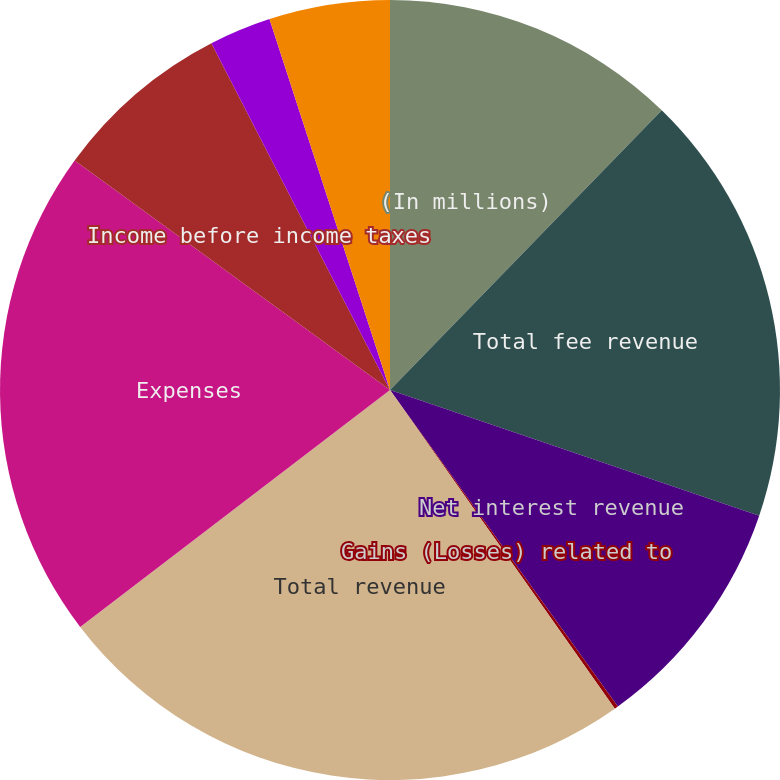<chart> <loc_0><loc_0><loc_500><loc_500><pie_chart><fcel>(In millions)<fcel>Total fee revenue<fcel>Net interest revenue<fcel>Gains (Losses) related to<fcel>Total revenue<fcel>Expenses<fcel>Income before income taxes<fcel>Income tax expense<fcel>Net income<nl><fcel>12.27%<fcel>17.95%<fcel>9.85%<fcel>0.15%<fcel>24.39%<fcel>20.4%<fcel>7.42%<fcel>2.57%<fcel>5.0%<nl></chart> 